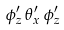Convert formula to latex. <formula><loc_0><loc_0><loc_500><loc_500>\phi ^ { \prime } _ { z } \, \theta ^ { \prime } _ { x } \, \phi ^ { \prime } _ { z }</formula> 